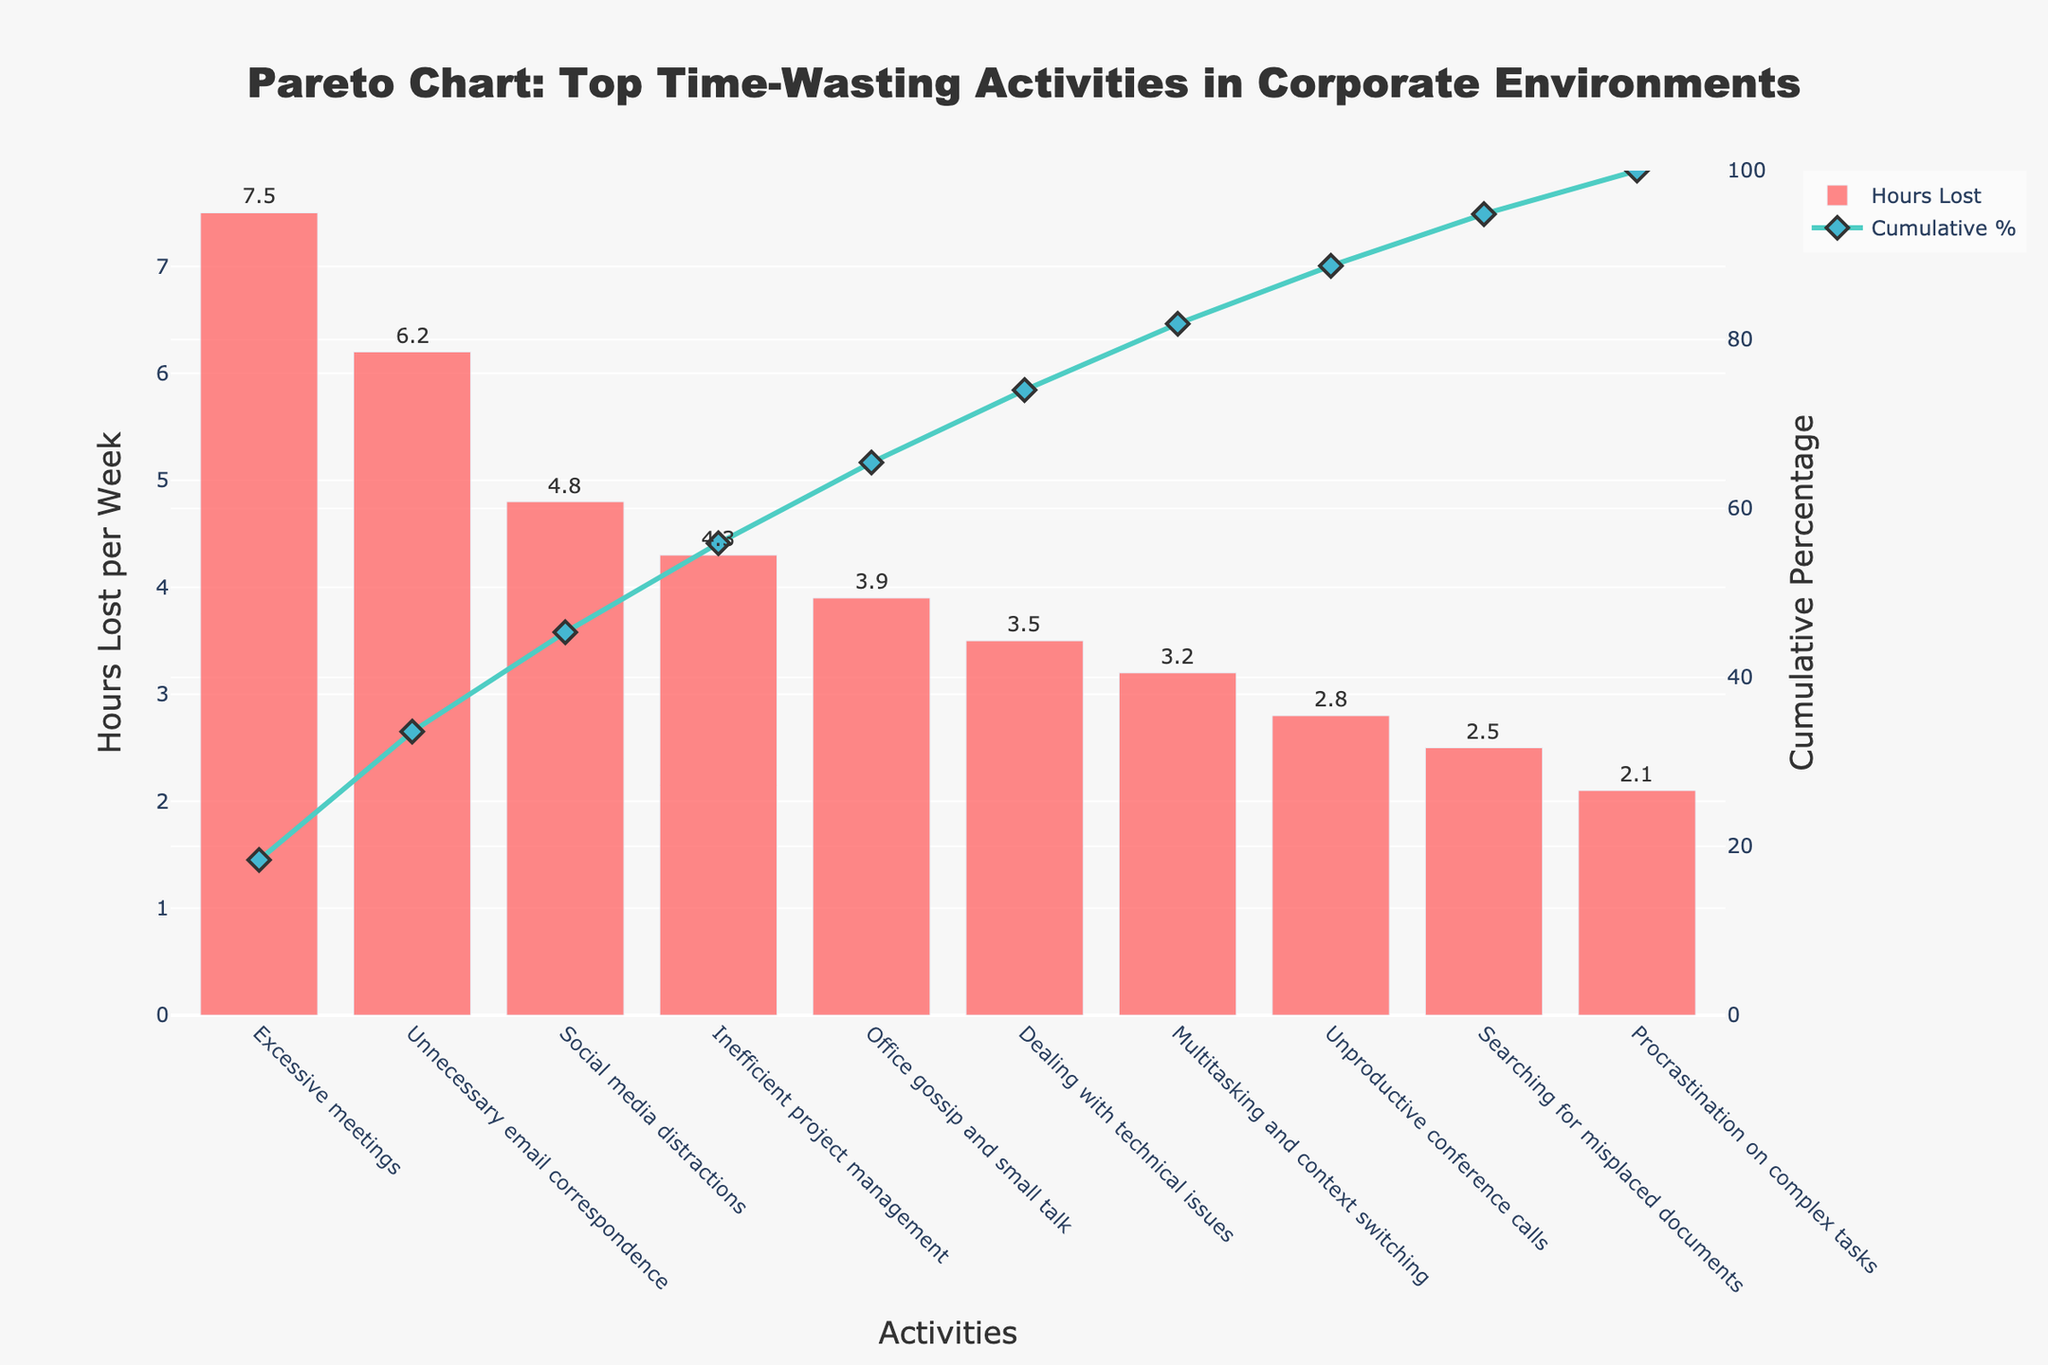What's the title of the figure? The title is usually at the top of the chart and it provides an overview of what the chart is about. In this case, the title is clearly visible at the top center of the chart.
Answer: Pareto Chart: Top Time-Wasting Activities in Corporate Environments What activity wastes the most hours per week? The activity that wastes the most hours per week is represented by the tallest bar in the chart. By looking at the chart, we can see that the bar for "Excessive meetings" is the tallest.
Answer: Excessive meetings What's the total number of hours lost per week for the top three activities? To find the total number of hours lost per week for the top three activities, we sum their individual hours: 7.5 (Excessive meetings) + 6.2 (Unnecessary email correspondence) + 4.8 (Social media distractions).
Answer: 18.5 Which activity is associated with the first significant drop in the cumulative percentage line? A significant drop in the cumulative percentage line corresponds to a less steep slope after the preceding activities with higher values. Here, the significant drop happens after "Unnecessary email correspondence".
Answer: Social media distractions What’s the cumulative percentage for the top four time-wasting activities? The cumulative percentage for the top four activities can be found by looking at the cumulative percentage line at the fourth activity. The figure shows the cumulative values increasing, and after "Inefficient project management", the cumulative percentage is around 64.6%.
Answer: 64.6% Which time-wasting activity is represented by the second smallest bar? The second smallest bar represents the activity with the second least hours lost. By visually identifying this bar, we can see that it corresponds to "Searching for misplaced documents".
Answer: Searching for misplaced documents How many activities contribute to 50% of the total hours lost per week? By looking at the cumulative percentage line, we identify the point where it crosses the 50% mark. This occurs between the second and third activities. Therefore, the first two activities contribute to 50% of the total hours lost per week.
Answer: 2 What’s the difference in hours lost per week between "Excessive meetings" and "Dealing with technical issues"? The hours lost per week for "Excessive meetings" is 7.5 and for "Dealing with technical issues" is 3.5. The difference is calculated as 7.5 - 3.5.
Answer: 4.0 Which activity has a cumulative percentage just below 75%? The cumulative percentage line indicates that just below 75% is around the point after "Multitasking and context switching".
Answer: Unproductive conference calls 